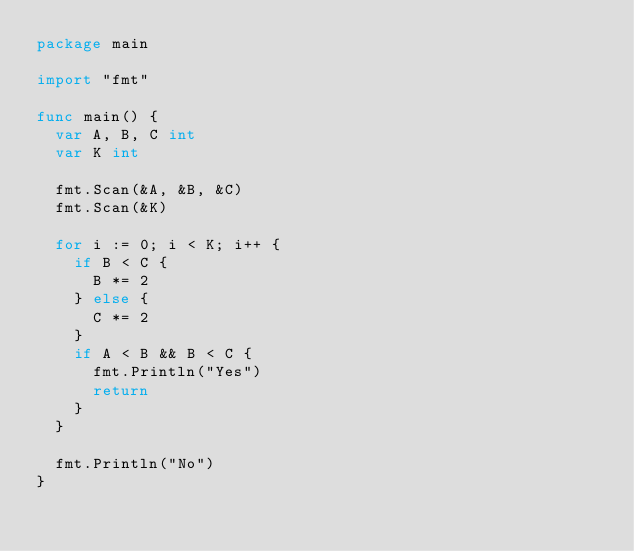<code> <loc_0><loc_0><loc_500><loc_500><_Go_>package main

import "fmt"

func main() {
	var A, B, C int
	var K int

	fmt.Scan(&A, &B, &C)
	fmt.Scan(&K)

	for i := 0; i < K; i++ {
		if B < C {
			B *= 2
		} else {
			C *= 2
		}
		if A < B && B < C {
			fmt.Println("Yes")
			return
		}
	}

	fmt.Println("No")
}
</code> 